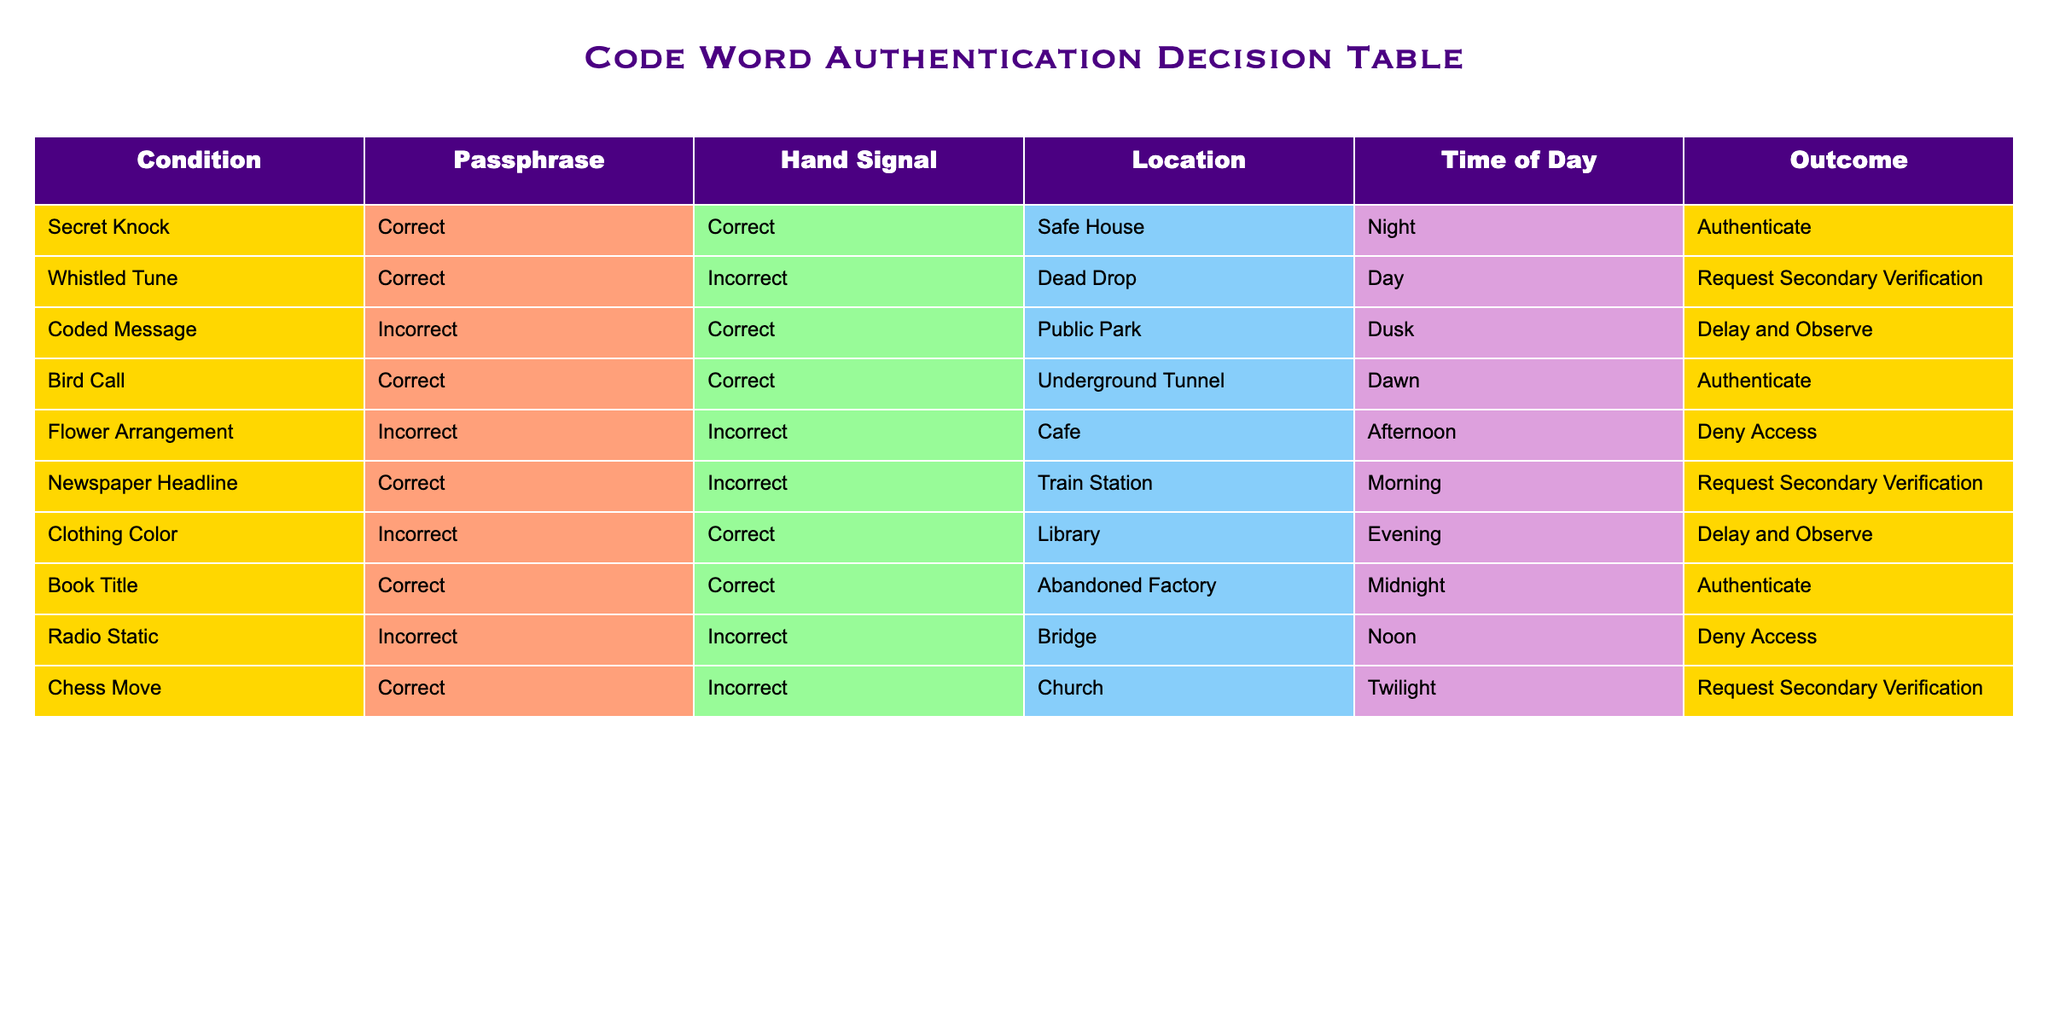What is the outcome when the passphrase is "Coded Message"? Looking at the "Coded Message" row, the passphrase is marked as "Incorrect", and the corresponding outcome is "Delay and Observe".
Answer: Delay and Observe How many outcomes result in "Authenticate"? The outcomes are listed in the table. Counting those that state "Authenticate", we find three rows: "Secret Knock", "Bird Call", and "Book Title". Therefore, the count is 3.
Answer: 3 Is the hand signal "Correct" ever paired with a "Deny Access" outcome? Reviewing the rows, there are no instances where the hand signal is "Correct" and the outcome is "Deny Access". The only outcomes for "Deny Access" are paired with "Incorrect" passphrases or signals.
Answer: No What are the different locations where "Request Secondary Verification" occurs? The locations corresponding to "Request Secondary Verification" are identified in the table. They appear in two rows: at "Dead Drop" and "Train Station". Therefore, the unique locations are "Dead Drop" and "Train Station".
Answer: Dead Drop, Train Station What is the total number of different outcomes listed in the table? Counting the unique outcomes in the table, we identify five distinct outcomes: "Authenticate", "Request Secondary Verification", "Delay and Observe", and "Deny Access". Each outcome appears at least once. The total number is 4 unique outcomes.
Answer: 4 Which passphrase, if any, leads to a "Deny Access" outcome? Referring to the table, we find that the "Flower Arrangement" and "Radio Static" passphrases lead to the "Deny Access" outcome. Thus, both passphrases are relevant for this question.
Answer: Flower Arrangement, Radio Static What is the ratio of outcomes that lead to "Authenticate" versus "Deny Access"? We identified 3 outcomes for "Authenticate" and 2 outcomes for "Deny Access". The ratio is therefore 3:2.
Answer: 3:2 Can you identify any patterns in the time of day correlated with "Request Secondary Verification"? Observing the table, both instances of "Request Secondary Verification" occur during the day: one in the "Day" and the other in the "Morning". This suggests that both outcomes share a daytime occurrence.
Answer: Daytime occurrences Which hand signal is most frequently associated with an "Authenticate" outcome? Examining the rows for "Authenticate", we find that the hand signals of "Correct" are recurrent, specifically paired with "Secret Knock", "Bird Call", and "Book Title". Thus, "Correct" is the most frequent hand signal associated with "Authenticate".
Answer: Correct 